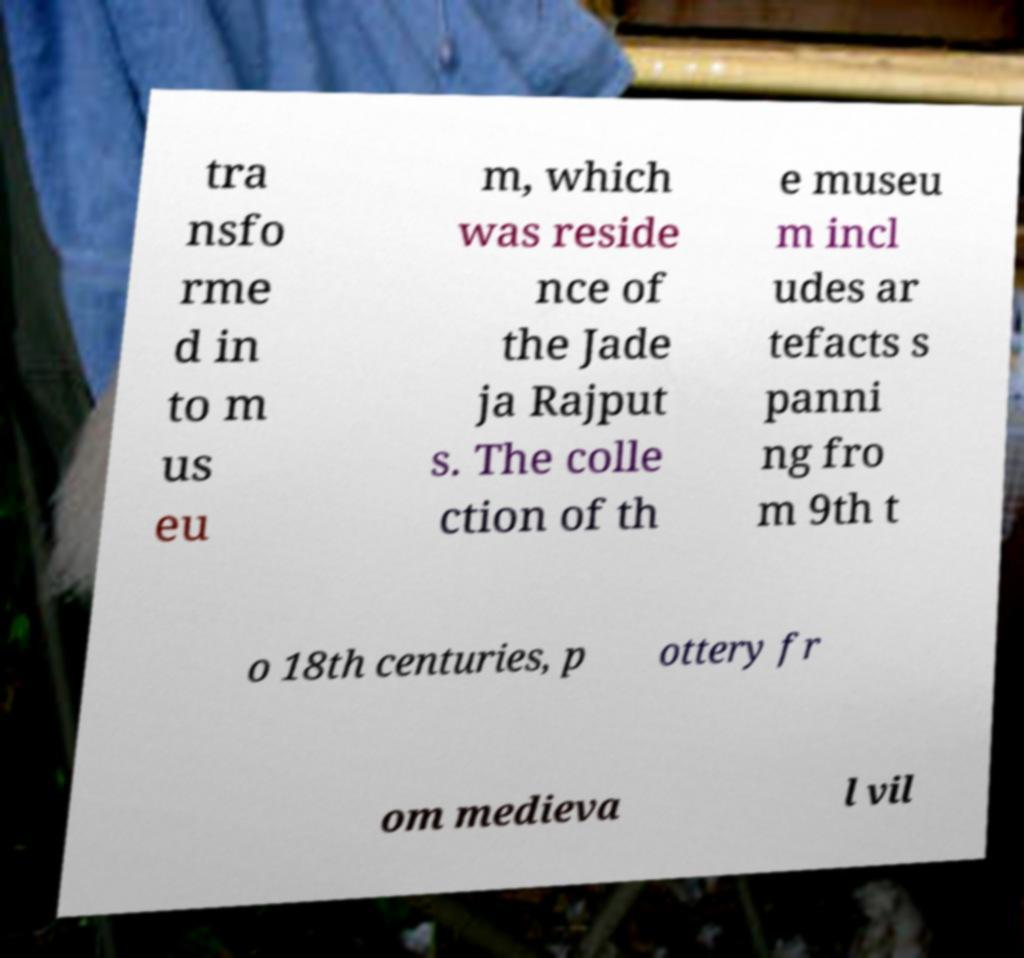I need the written content from this picture converted into text. Can you do that? tra nsfo rme d in to m us eu m, which was reside nce of the Jade ja Rajput s. The colle ction of th e museu m incl udes ar tefacts s panni ng fro m 9th t o 18th centuries, p ottery fr om medieva l vil 